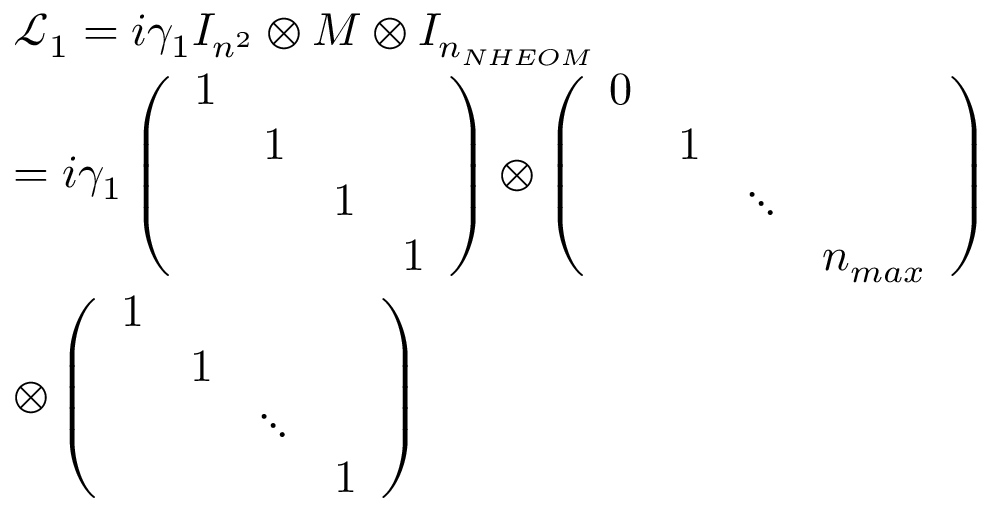Convert formula to latex. <formula><loc_0><loc_0><loc_500><loc_500>\begin{array} { r l } & { { \mathcal { L } _ { 1 } } = i { { \gamma } _ { 1 } } { { I } _ { { { n } ^ { 2 } } } } \otimes M \otimes { { I } _ { { { n } _ { N H E O M } } } } } \\ & { = i { { \gamma } _ { 1 } } \left ( \begin{array} { l l l l } { 1 } & { 1 } & { 1 } & { 1 } \end{array} \right ) \otimes \left ( \begin{array} { l l l l } { 0 } & { 1 } & { \ddots } & { { { n } _ { \max } } } \end{array} \right ) } \\ & { \otimes \left ( \begin{array} { l l l l } { 1 } & { 1 } & { \ddots } & { 1 } \end{array} \right ) } \end{array}</formula> 